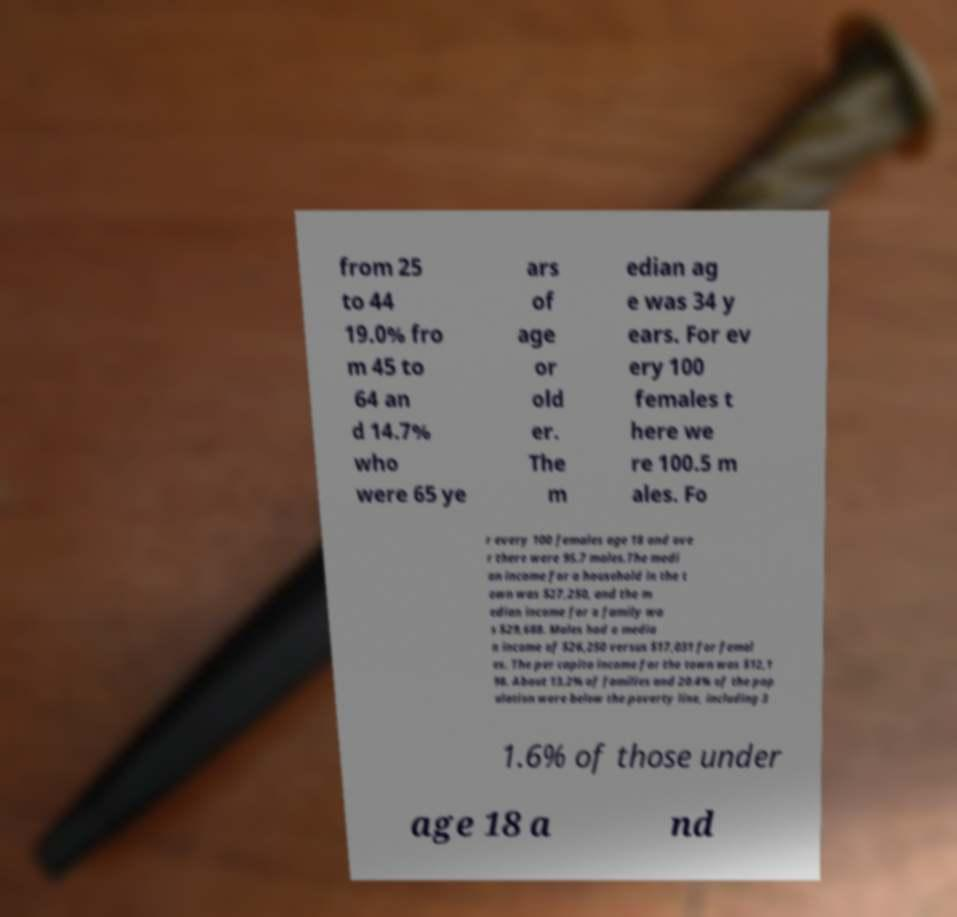Can you accurately transcribe the text from the provided image for me? from 25 to 44 19.0% fro m 45 to 64 an d 14.7% who were 65 ye ars of age or old er. The m edian ag e was 34 y ears. For ev ery 100 females t here we re 100.5 m ales. Fo r every 100 females age 18 and ove r there were 95.7 males.The medi an income for a household in the t own was $27,250, and the m edian income for a family wa s $29,688. Males had a media n income of $26,250 versus $17,031 for femal es. The per capita income for the town was $12,1 98. About 13.2% of families and 20.4% of the pop ulation were below the poverty line, including 3 1.6% of those under age 18 a nd 